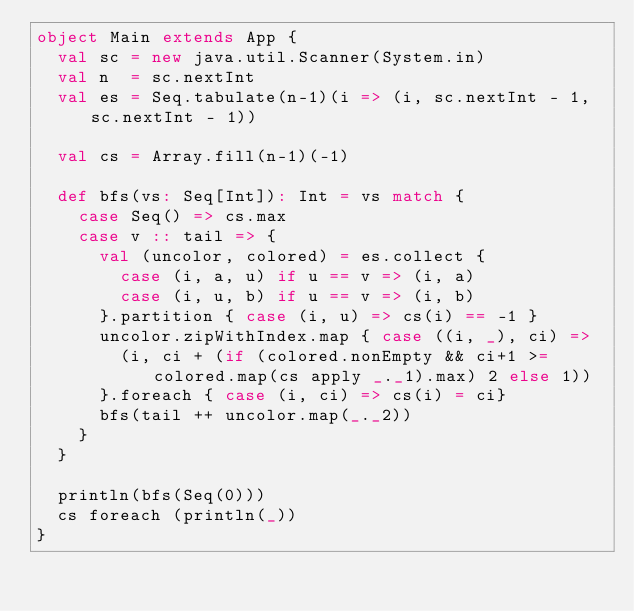Convert code to text. <code><loc_0><loc_0><loc_500><loc_500><_Scala_>object Main extends App {
	val sc = new java.util.Scanner(System.in)
	val n  = sc.nextInt
	val es = Seq.tabulate(n-1)(i => (i, sc.nextInt - 1, sc.nextInt - 1))
	
	val cs = Array.fill(n-1)(-1)
	
	def bfs(vs: Seq[Int]): Int = vs match {
		case Seq() => cs.max
		case v :: tail => {
			val (uncolor, colored) = es.collect {
				case (i, a, u) if u == v => (i, a)
				case (i, u, b) if u == v => (i, b)
			}.partition { case (i, u) => cs(i) == -1 }
			uncolor.zipWithIndex.map { case ((i, _), ci) =>
				(i, ci + (if (colored.nonEmpty && ci+1 >= colored.map(cs apply _._1).max) 2 else 1))
			}.foreach { case (i, ci) => cs(i) = ci}
			bfs(tail ++ uncolor.map(_._2))
		}
	}
	
	println(bfs(Seq(0)))
	cs foreach (println(_))
}</code> 